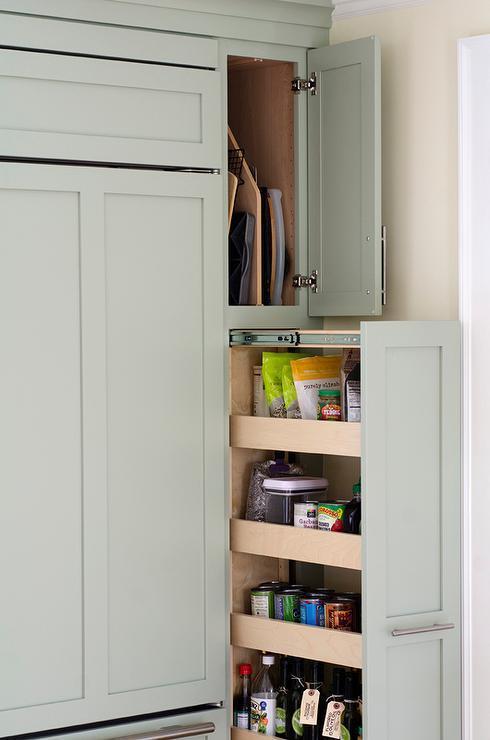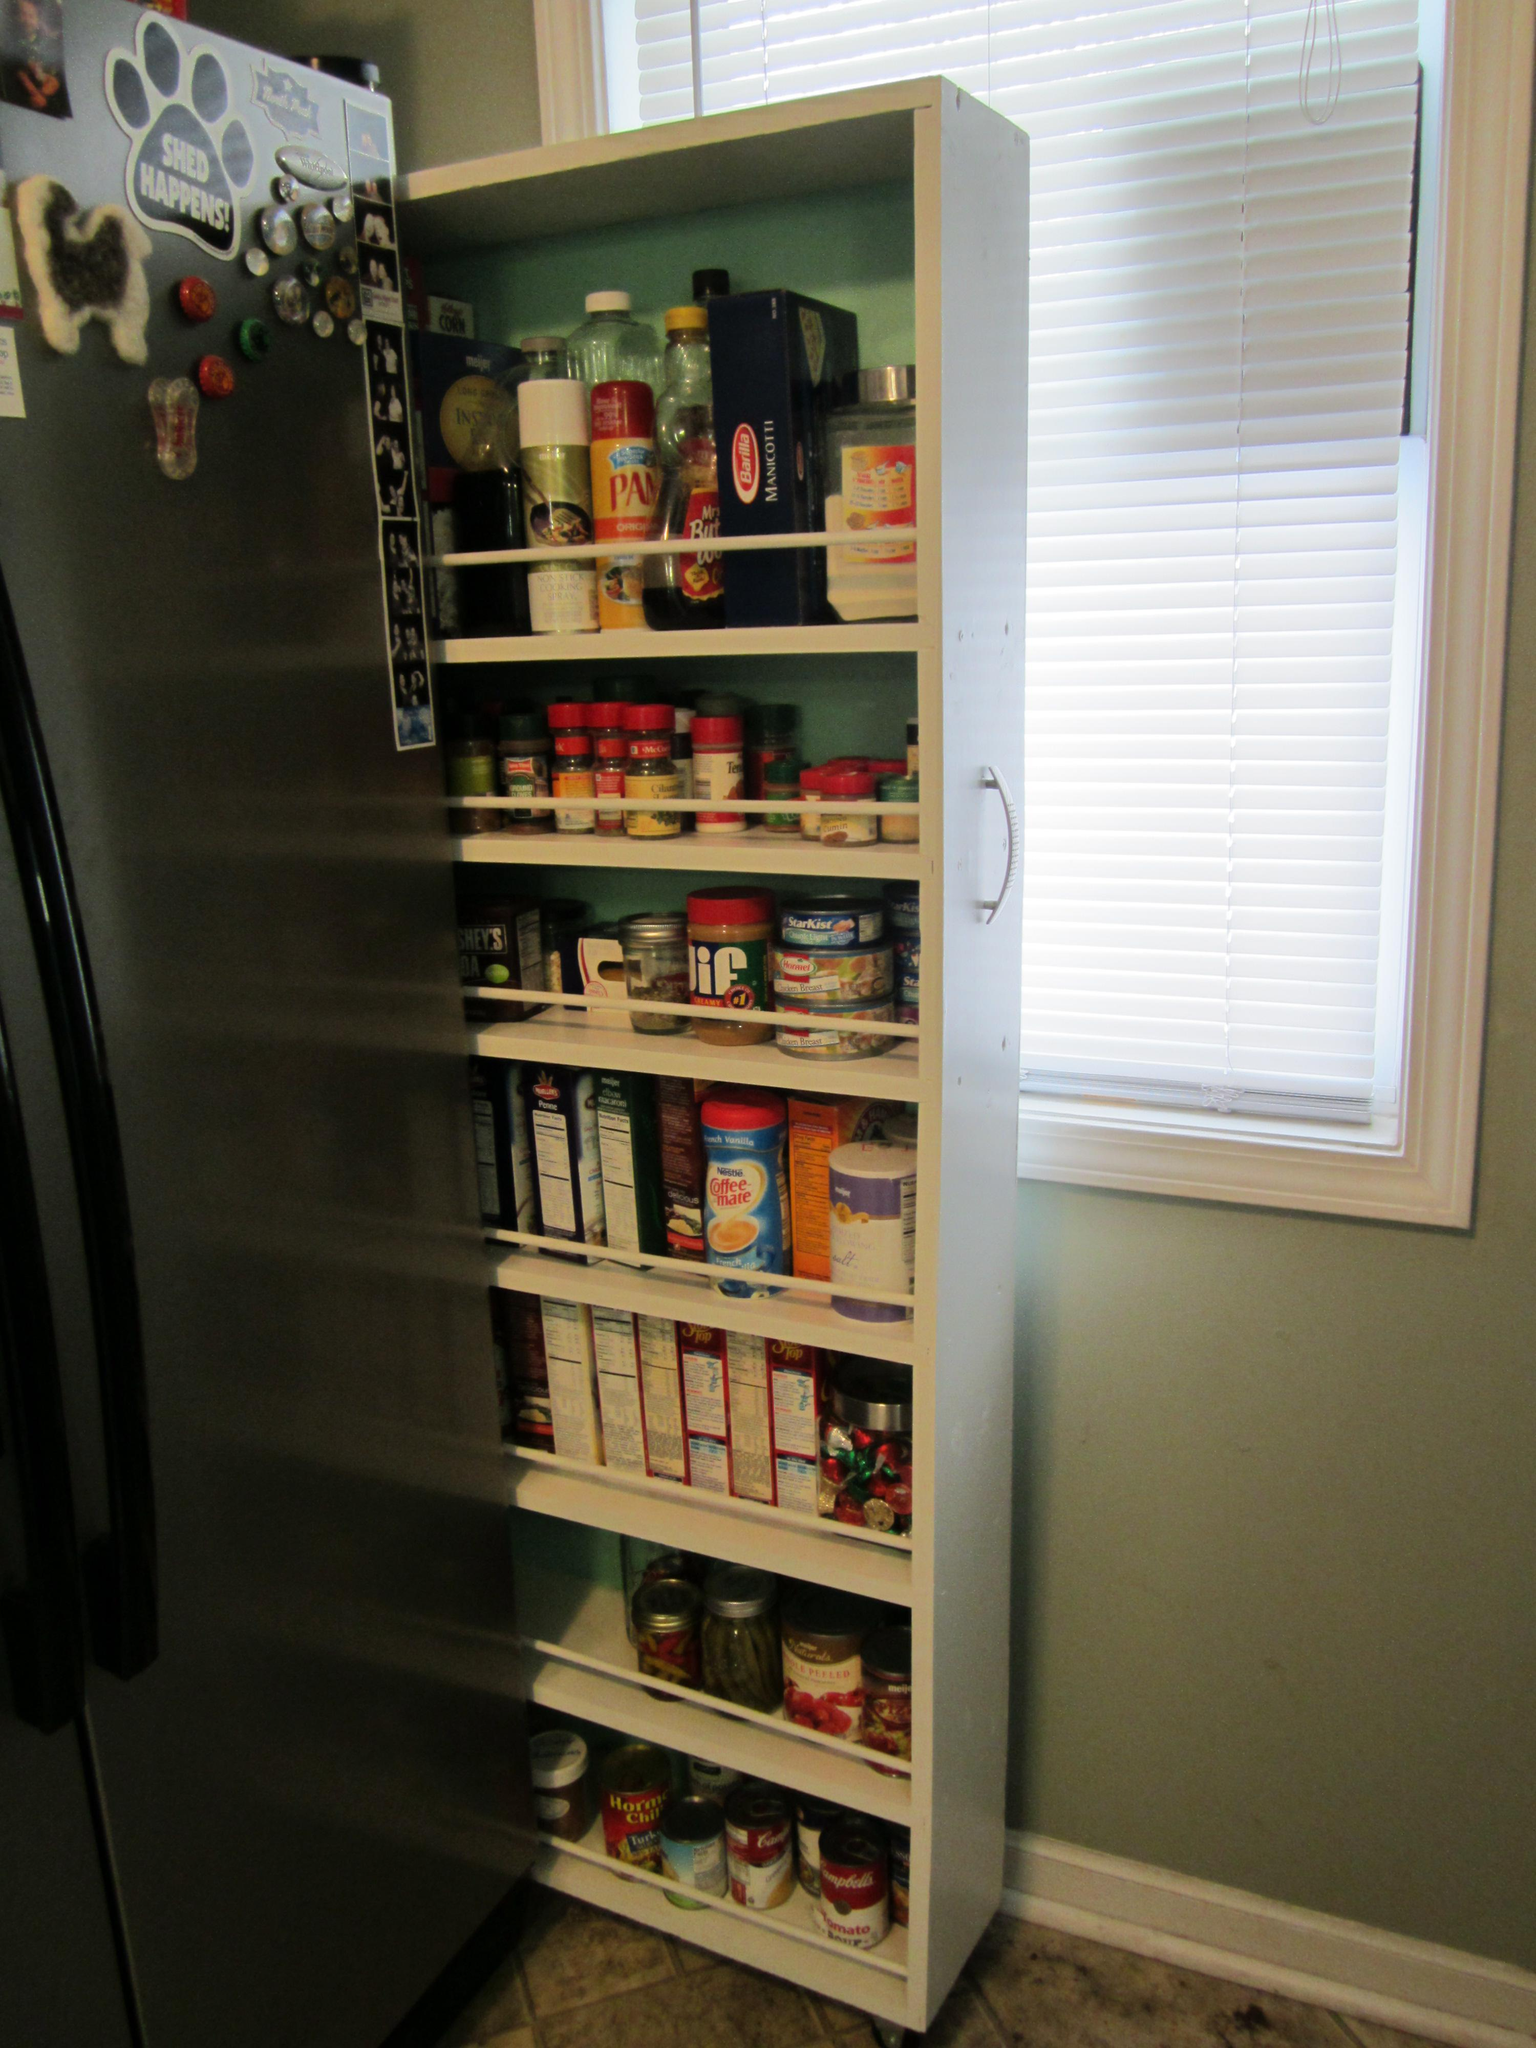The first image is the image on the left, the second image is the image on the right. Examine the images to the left and right. Is the description "The right image shows a narrow filled pantry with a handle pulled out from behind a stainless steel refrigerator and in front of a doorway." accurate? Answer yes or no. No. The first image is the image on the left, the second image is the image on the right. Assess this claim about the two images: "Facing the refridgerator, the sliding pantry is on its left side.". Correct or not? Answer yes or no. No. 